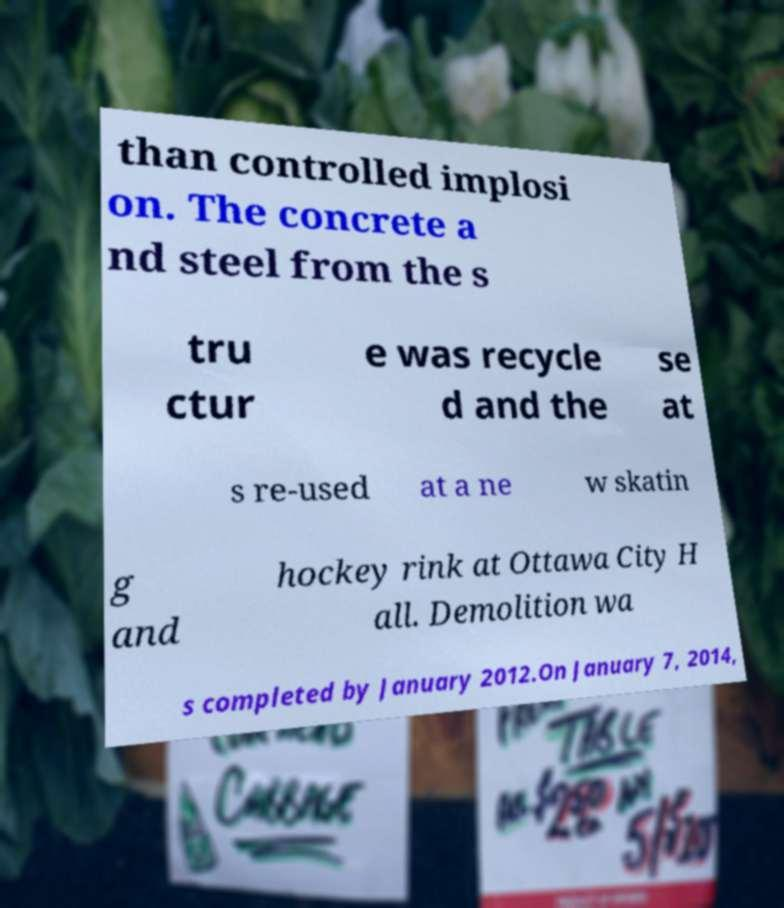I need the written content from this picture converted into text. Can you do that? than controlled implosi on. The concrete a nd steel from the s tru ctur e was recycle d and the se at s re-used at a ne w skatin g and hockey rink at Ottawa City H all. Demolition wa s completed by January 2012.On January 7, 2014, 